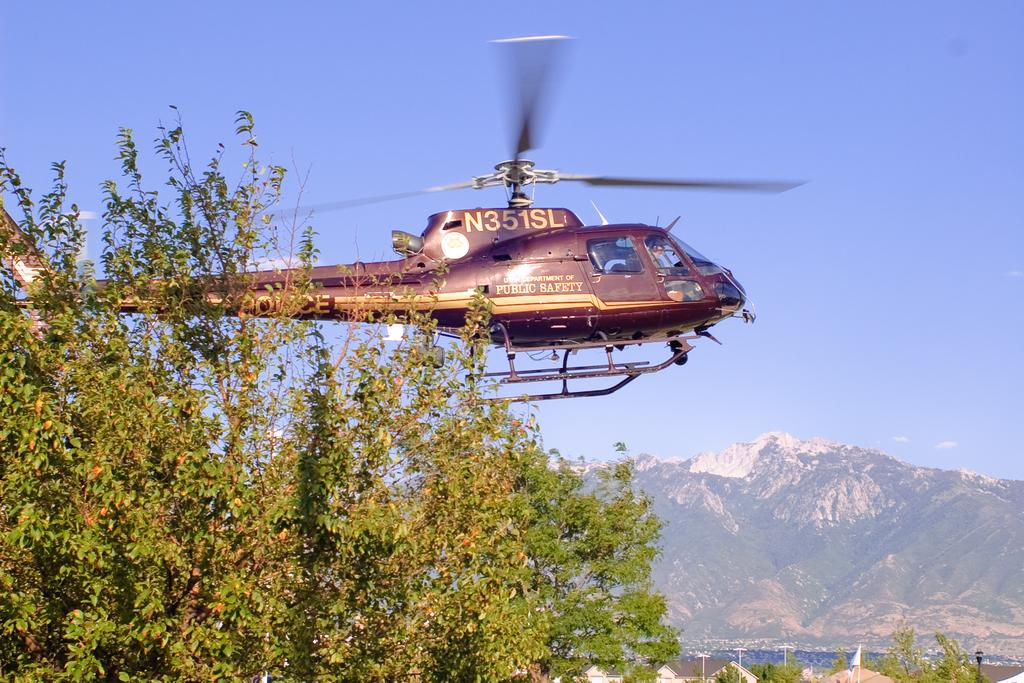<image>
Offer a succinct explanation of the picture presented. A helicopter with N351SD on the top of it. 